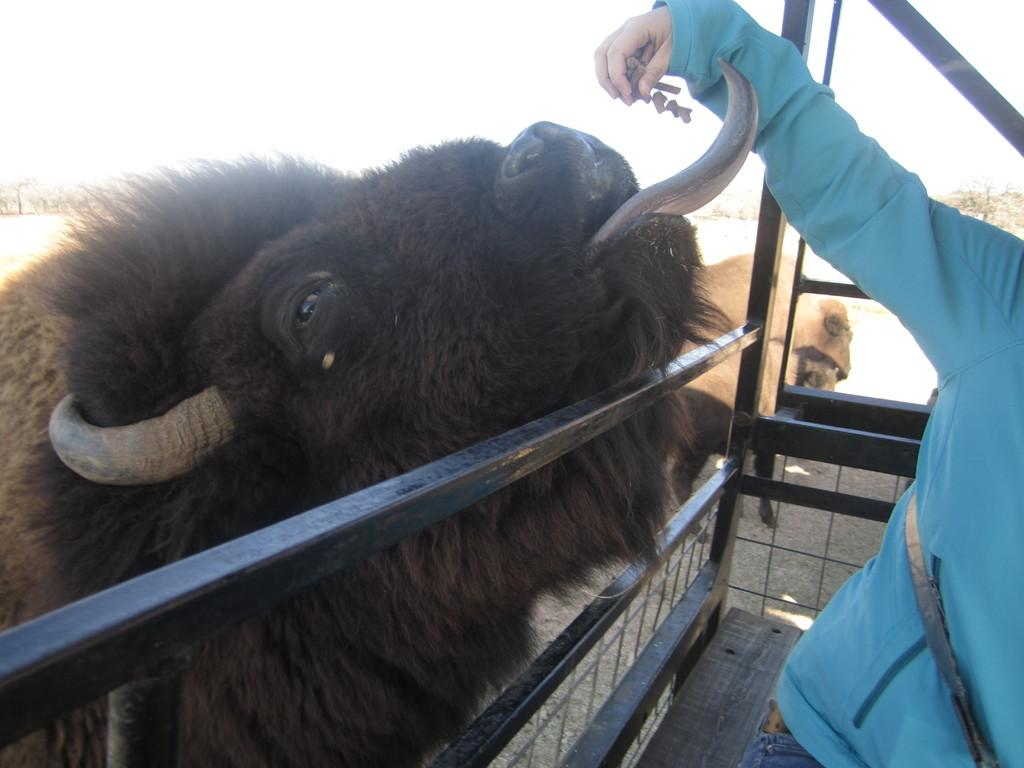What is happening in the image involving a person? The person in the image is giving food to an animal. What can be found in the image besides the person and the animal? There is a cage in the image. What is visible in the background of the image? There are trees in the background of the image. What type of detail can be seen on the quilt in the image? There is no quilt present in the image. What is the cow doing in the image? There is no cow present in the image. 